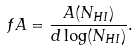<formula> <loc_0><loc_0><loc_500><loc_500>f A = \frac { A ( N _ { H I } ) } { d \log ( N _ { H I } ) } .</formula> 